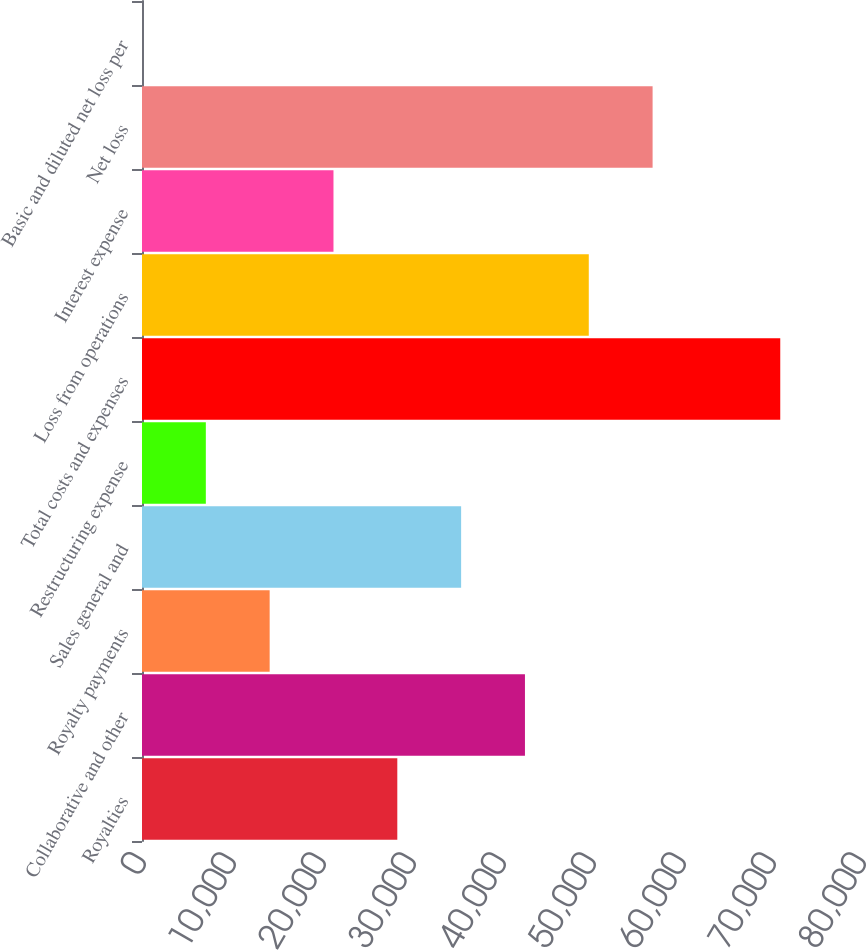Convert chart to OTSL. <chart><loc_0><loc_0><loc_500><loc_500><bar_chart><fcel>Royalties<fcel>Collaborative and other<fcel>Royalty payments<fcel>Sales general and<fcel>Restructuring expense<fcel>Total costs and expenses<fcel>Loss from operations<fcel>Interest expense<fcel>Net loss<fcel>Basic and diluted net loss per<nl><fcel>28367.1<fcel>42550.4<fcel>14183.8<fcel>35458.8<fcel>7092.15<fcel>70917<fcel>49642.1<fcel>21275.5<fcel>56733.7<fcel>0.5<nl></chart> 